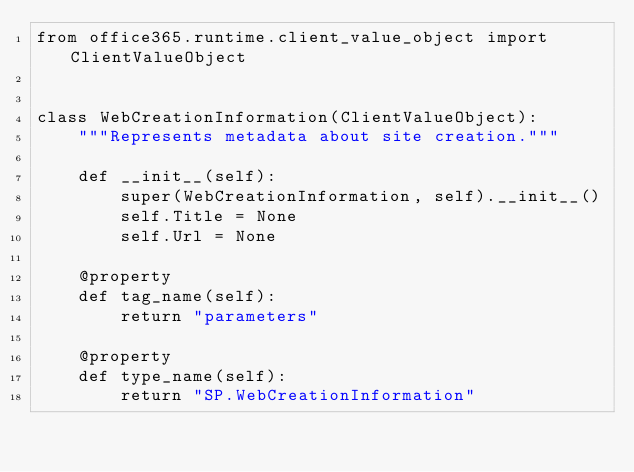<code> <loc_0><loc_0><loc_500><loc_500><_Python_>from office365.runtime.client_value_object import ClientValueObject


class WebCreationInformation(ClientValueObject):
    """Represents metadata about site creation."""

    def __init__(self):
        super(WebCreationInformation, self).__init__()
        self.Title = None
        self.Url = None

    @property
    def tag_name(self):
        return "parameters"

    @property
    def type_name(self):
        return "SP.WebCreationInformation"
</code> 